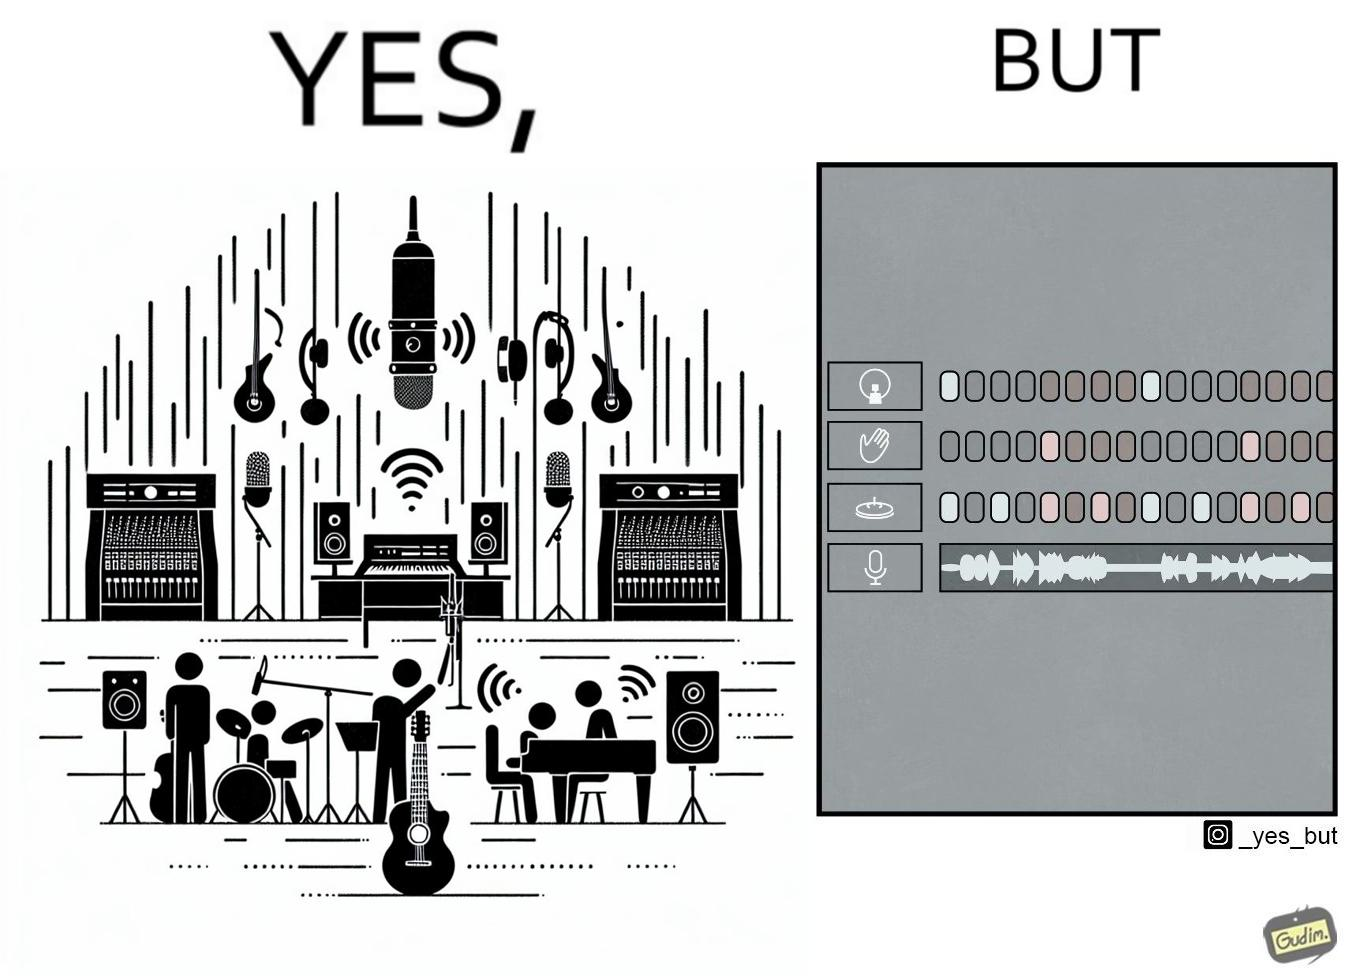Describe the satirical element in this image. The image overall is funny because even though people have great music studios and instruments to create and record music, they use electronic replacements of the musical instruments to achieve the task. 